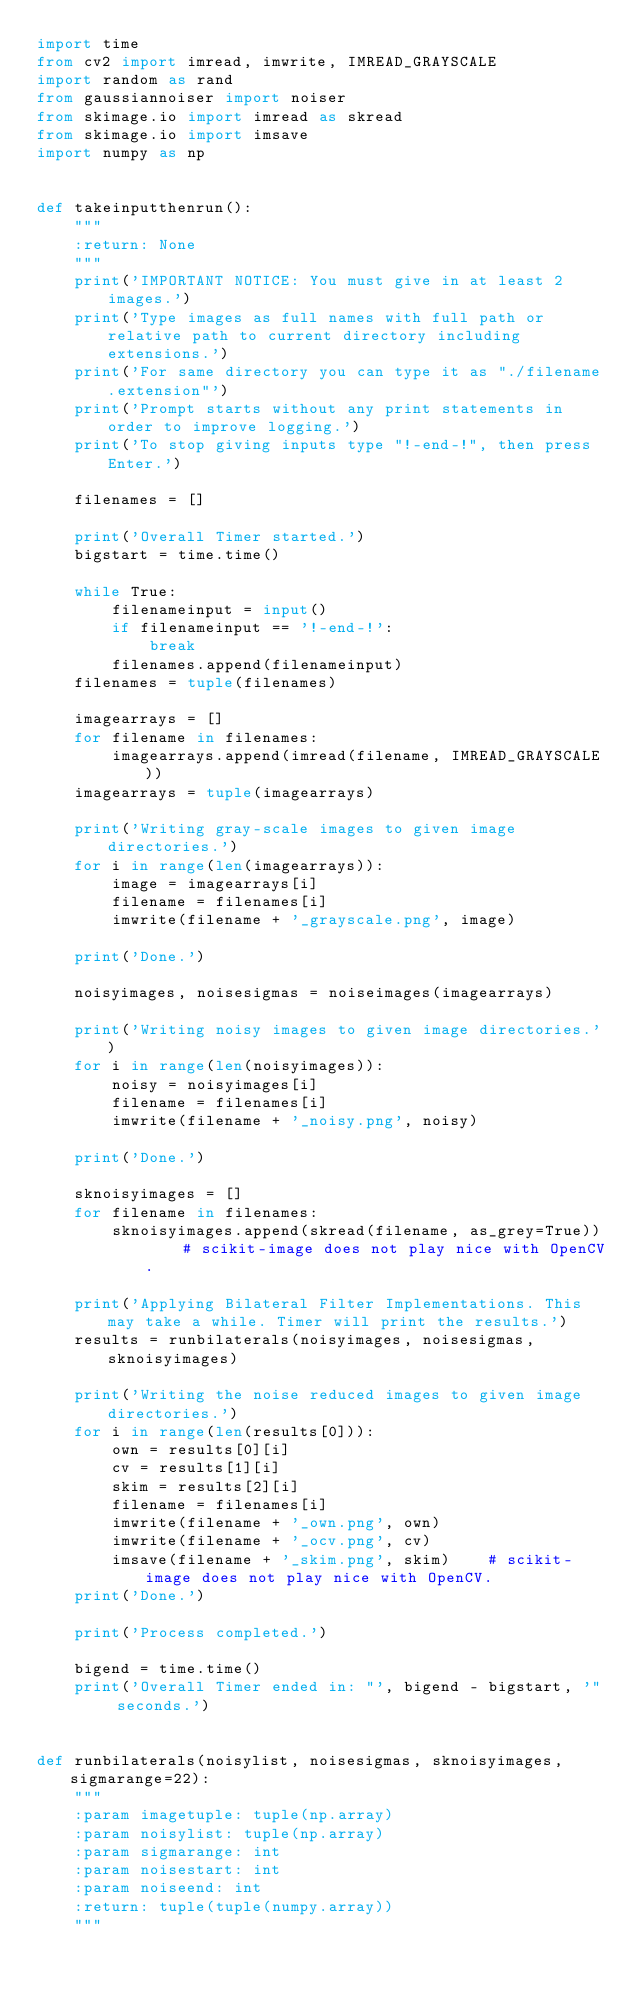<code> <loc_0><loc_0><loc_500><loc_500><_Python_>import time
from cv2 import imread, imwrite, IMREAD_GRAYSCALE
import random as rand
from gaussiannoiser import noiser
from skimage.io import imread as skread
from skimage.io import imsave
import numpy as np


def takeinputthenrun():
    """
    :return: None
    """
    print('IMPORTANT NOTICE: You must give in at least 2 images.')
    print('Type images as full names with full path or relative path to current directory including extensions.')
    print('For same directory you can type it as "./filename.extension"')
    print('Prompt starts without any print statements in order to improve logging.')
    print('To stop giving inputs type "!-end-!", then press Enter.')

    filenames = []

    print('Overall Timer started.')
    bigstart = time.time()

    while True:
        filenameinput = input()
        if filenameinput == '!-end-!':
            break
        filenames.append(filenameinput)
    filenames = tuple(filenames)

    imagearrays = []
    for filename in filenames:
        imagearrays.append(imread(filename, IMREAD_GRAYSCALE))
    imagearrays = tuple(imagearrays)

    print('Writing gray-scale images to given image directories.')
    for i in range(len(imagearrays)):
        image = imagearrays[i]
        filename = filenames[i]
        imwrite(filename + '_grayscale.png', image)

    print('Done.')

    noisyimages, noisesigmas = noiseimages(imagearrays)

    print('Writing noisy images to given image directories.')
    for i in range(len(noisyimages)):
        noisy = noisyimages[i]
        filename = filenames[i]
        imwrite(filename + '_noisy.png', noisy)

    print('Done.')

    sknoisyimages = []
    for filename in filenames:
        sknoisyimages.append(skread(filename, as_grey=True))    # scikit-image does not play nice with OpenCV.

    print('Applying Bilateral Filter Implementations. This may take a while. Timer will print the results.')
    results = runbilaterals(noisyimages, noisesigmas, sknoisyimages)

    print('Writing the noise reduced images to given image directories.')
    for i in range(len(results[0])):
        own = results[0][i]
        cv = results[1][i]
        skim = results[2][i]
        filename = filenames[i]
        imwrite(filename + '_own.png', own)
        imwrite(filename + '_ocv.png', cv)
        imsave(filename + '_skim.png', skim)    # scikit-image does not play nice with OpenCV.
    print('Done.')

    print('Process completed.')

    bigend = time.time()
    print('Overall Timer ended in: "', bigend - bigstart, '" seconds.')


def runbilaterals(noisylist, noisesigmas, sknoisyimages, sigmarange=22):
    """
    :param imagetuple: tuple(np.array)
    :param noisylist: tuple(np.array)
    :param sigmarange: int
    :param noisestart: int
    :param noiseend: int
    :return: tuple(tuple(numpy.array))
    """
</code> 